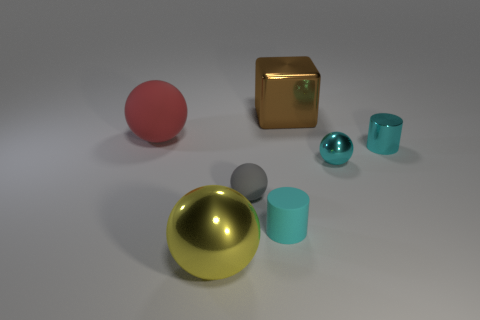How many big brown objects are right of the small cyan thing to the left of the big object that is to the right of the tiny gray matte object?
Keep it short and to the point. 1. Is the shape of the big yellow object the same as the matte object behind the tiny gray ball?
Provide a succinct answer. Yes. What color is the big thing that is both behind the gray sphere and in front of the big shiny block?
Your response must be concise. Red. There is a tiny cylinder that is left of the tiny ball that is right of the large shiny object that is to the right of the tiny gray object; what is it made of?
Provide a succinct answer. Rubber. What material is the tiny gray ball?
Ensure brevity in your answer.  Rubber. There is a gray object that is the same shape as the large yellow object; what size is it?
Make the answer very short. Small. Does the tiny metallic sphere have the same color as the metallic cylinder?
Provide a short and direct response. Yes. What number of other things are the same material as the brown thing?
Give a very brief answer. 3. Are there an equal number of small things behind the big matte sphere and spheres?
Ensure brevity in your answer.  No. Is the size of the cyan cylinder that is behind the matte cylinder the same as the gray thing?
Ensure brevity in your answer.  Yes. 